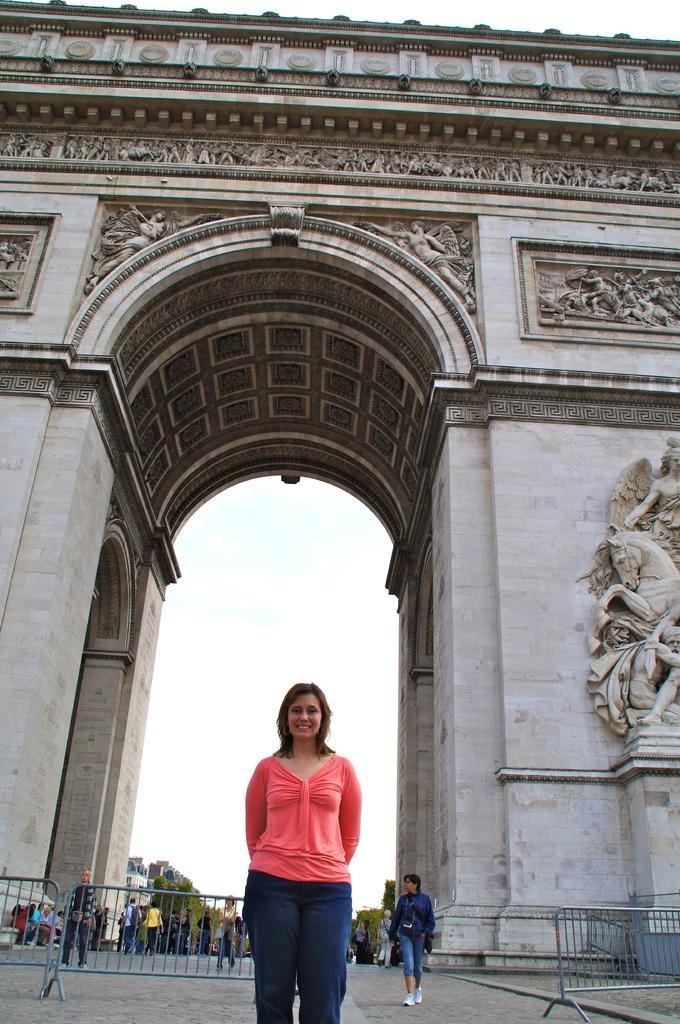Could you give a brief overview of what you see in this image? There is a lady standing in front of an entrance. In the back there are barricades. Also there are many people. On the entrance there are sculptures. In the background there is sky. 